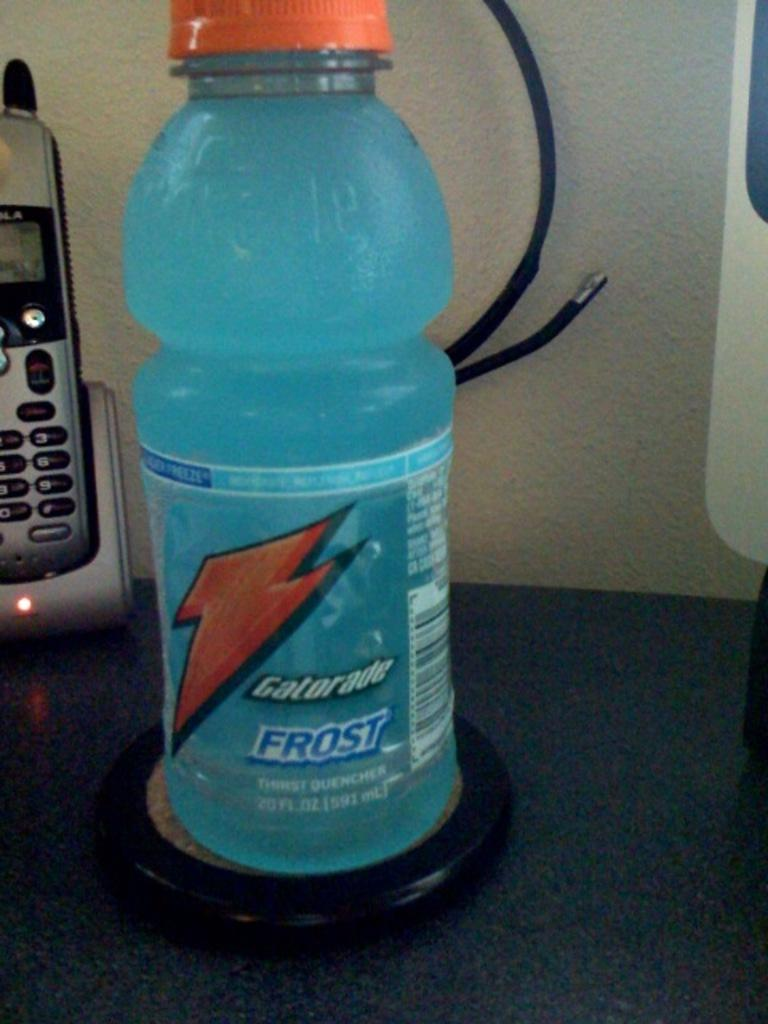<image>
Describe the image concisely. Frost Gatorade looking cold sits in front of a silver home phone on a counter. 